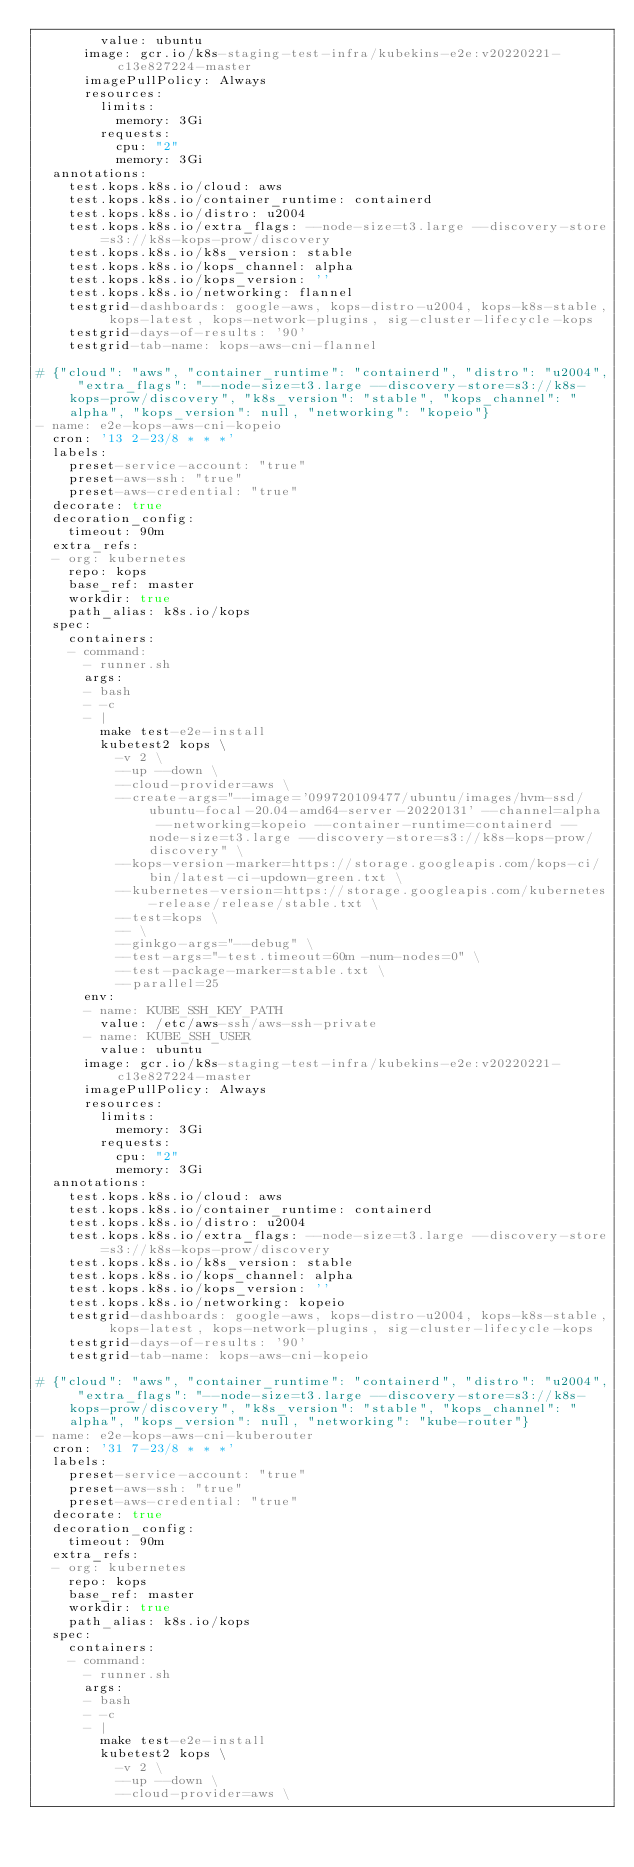<code> <loc_0><loc_0><loc_500><loc_500><_YAML_>        value: ubuntu
      image: gcr.io/k8s-staging-test-infra/kubekins-e2e:v20220221-c13e827224-master
      imagePullPolicy: Always
      resources:
        limits:
          memory: 3Gi
        requests:
          cpu: "2"
          memory: 3Gi
  annotations:
    test.kops.k8s.io/cloud: aws
    test.kops.k8s.io/container_runtime: containerd
    test.kops.k8s.io/distro: u2004
    test.kops.k8s.io/extra_flags: --node-size=t3.large --discovery-store=s3://k8s-kops-prow/discovery
    test.kops.k8s.io/k8s_version: stable
    test.kops.k8s.io/kops_channel: alpha
    test.kops.k8s.io/kops_version: ''
    test.kops.k8s.io/networking: flannel
    testgrid-dashboards: google-aws, kops-distro-u2004, kops-k8s-stable, kops-latest, kops-network-plugins, sig-cluster-lifecycle-kops
    testgrid-days-of-results: '90'
    testgrid-tab-name: kops-aws-cni-flannel

# {"cloud": "aws", "container_runtime": "containerd", "distro": "u2004", "extra_flags": "--node-size=t3.large --discovery-store=s3://k8s-kops-prow/discovery", "k8s_version": "stable", "kops_channel": "alpha", "kops_version": null, "networking": "kopeio"}
- name: e2e-kops-aws-cni-kopeio
  cron: '13 2-23/8 * * *'
  labels:
    preset-service-account: "true"
    preset-aws-ssh: "true"
    preset-aws-credential: "true"
  decorate: true
  decoration_config:
    timeout: 90m
  extra_refs:
  - org: kubernetes
    repo: kops
    base_ref: master
    workdir: true
    path_alias: k8s.io/kops
  spec:
    containers:
    - command:
      - runner.sh
      args:
      - bash
      - -c
      - |
        make test-e2e-install
        kubetest2 kops \
          -v 2 \
          --up --down \
          --cloud-provider=aws \
          --create-args="--image='099720109477/ubuntu/images/hvm-ssd/ubuntu-focal-20.04-amd64-server-20220131' --channel=alpha --networking=kopeio --container-runtime=containerd --node-size=t3.large --discovery-store=s3://k8s-kops-prow/discovery" \
          --kops-version-marker=https://storage.googleapis.com/kops-ci/bin/latest-ci-updown-green.txt \
          --kubernetes-version=https://storage.googleapis.com/kubernetes-release/release/stable.txt \
          --test=kops \
          -- \
          --ginkgo-args="--debug" \
          --test-args="-test.timeout=60m -num-nodes=0" \
          --test-package-marker=stable.txt \
          --parallel=25
      env:
      - name: KUBE_SSH_KEY_PATH
        value: /etc/aws-ssh/aws-ssh-private
      - name: KUBE_SSH_USER
        value: ubuntu
      image: gcr.io/k8s-staging-test-infra/kubekins-e2e:v20220221-c13e827224-master
      imagePullPolicy: Always
      resources:
        limits:
          memory: 3Gi
        requests:
          cpu: "2"
          memory: 3Gi
  annotations:
    test.kops.k8s.io/cloud: aws
    test.kops.k8s.io/container_runtime: containerd
    test.kops.k8s.io/distro: u2004
    test.kops.k8s.io/extra_flags: --node-size=t3.large --discovery-store=s3://k8s-kops-prow/discovery
    test.kops.k8s.io/k8s_version: stable
    test.kops.k8s.io/kops_channel: alpha
    test.kops.k8s.io/kops_version: ''
    test.kops.k8s.io/networking: kopeio
    testgrid-dashboards: google-aws, kops-distro-u2004, kops-k8s-stable, kops-latest, kops-network-plugins, sig-cluster-lifecycle-kops
    testgrid-days-of-results: '90'
    testgrid-tab-name: kops-aws-cni-kopeio

# {"cloud": "aws", "container_runtime": "containerd", "distro": "u2004", "extra_flags": "--node-size=t3.large --discovery-store=s3://k8s-kops-prow/discovery", "k8s_version": "stable", "kops_channel": "alpha", "kops_version": null, "networking": "kube-router"}
- name: e2e-kops-aws-cni-kuberouter
  cron: '31 7-23/8 * * *'
  labels:
    preset-service-account: "true"
    preset-aws-ssh: "true"
    preset-aws-credential: "true"
  decorate: true
  decoration_config:
    timeout: 90m
  extra_refs:
  - org: kubernetes
    repo: kops
    base_ref: master
    workdir: true
    path_alias: k8s.io/kops
  spec:
    containers:
    - command:
      - runner.sh
      args:
      - bash
      - -c
      - |
        make test-e2e-install
        kubetest2 kops \
          -v 2 \
          --up --down \
          --cloud-provider=aws \</code> 